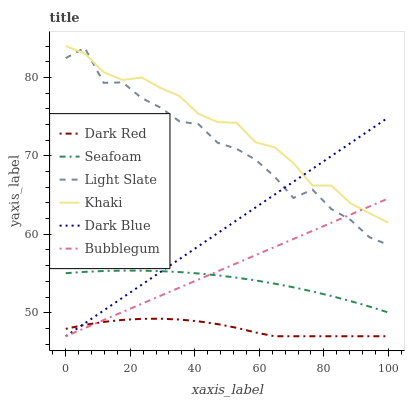Does Dark Red have the minimum area under the curve?
Answer yes or no. Yes. Does Khaki have the maximum area under the curve?
Answer yes or no. Yes. Does Light Slate have the minimum area under the curve?
Answer yes or no. No. Does Light Slate have the maximum area under the curve?
Answer yes or no. No. Is Bubblegum the smoothest?
Answer yes or no. Yes. Is Light Slate the roughest?
Answer yes or no. Yes. Is Dark Red the smoothest?
Answer yes or no. No. Is Dark Red the roughest?
Answer yes or no. No. Does Dark Red have the lowest value?
Answer yes or no. Yes. Does Light Slate have the lowest value?
Answer yes or no. No. Does Khaki have the highest value?
Answer yes or no. Yes. Does Light Slate have the highest value?
Answer yes or no. No. Is Seafoam less than Khaki?
Answer yes or no. Yes. Is Light Slate greater than Seafoam?
Answer yes or no. Yes. Does Dark Blue intersect Bubblegum?
Answer yes or no. Yes. Is Dark Blue less than Bubblegum?
Answer yes or no. No. Is Dark Blue greater than Bubblegum?
Answer yes or no. No. Does Seafoam intersect Khaki?
Answer yes or no. No. 